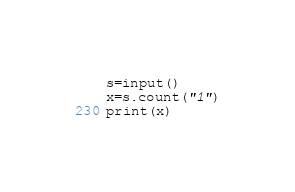Convert code to text. <code><loc_0><loc_0><loc_500><loc_500><_Python_>s=input()
x=s.count("1")
print(x)</code> 